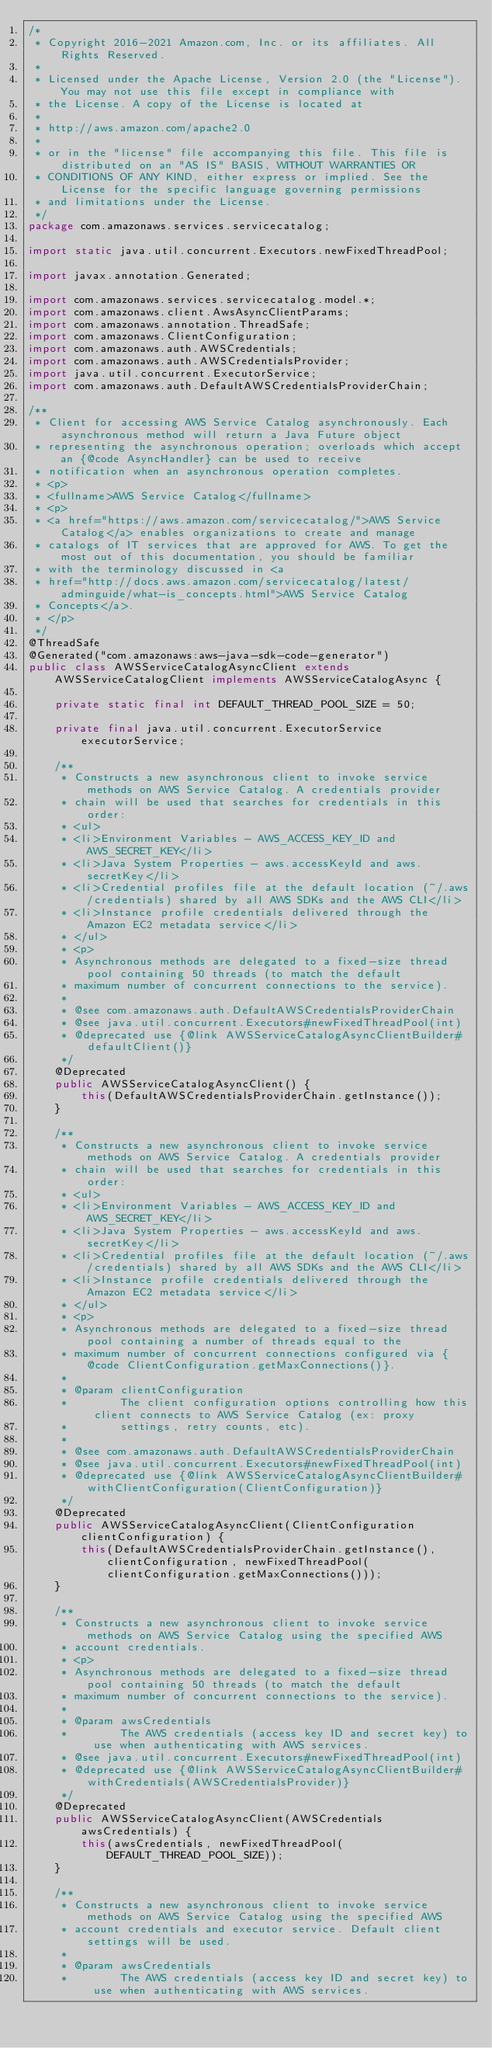<code> <loc_0><loc_0><loc_500><loc_500><_Java_>/*
 * Copyright 2016-2021 Amazon.com, Inc. or its affiliates. All Rights Reserved.
 * 
 * Licensed under the Apache License, Version 2.0 (the "License"). You may not use this file except in compliance with
 * the License. A copy of the License is located at
 * 
 * http://aws.amazon.com/apache2.0
 * 
 * or in the "license" file accompanying this file. This file is distributed on an "AS IS" BASIS, WITHOUT WARRANTIES OR
 * CONDITIONS OF ANY KIND, either express or implied. See the License for the specific language governing permissions
 * and limitations under the License.
 */
package com.amazonaws.services.servicecatalog;

import static java.util.concurrent.Executors.newFixedThreadPool;

import javax.annotation.Generated;

import com.amazonaws.services.servicecatalog.model.*;
import com.amazonaws.client.AwsAsyncClientParams;
import com.amazonaws.annotation.ThreadSafe;
import com.amazonaws.ClientConfiguration;
import com.amazonaws.auth.AWSCredentials;
import com.amazonaws.auth.AWSCredentialsProvider;
import java.util.concurrent.ExecutorService;
import com.amazonaws.auth.DefaultAWSCredentialsProviderChain;

/**
 * Client for accessing AWS Service Catalog asynchronously. Each asynchronous method will return a Java Future object
 * representing the asynchronous operation; overloads which accept an {@code AsyncHandler} can be used to receive
 * notification when an asynchronous operation completes.
 * <p>
 * <fullname>AWS Service Catalog</fullname>
 * <p>
 * <a href="https://aws.amazon.com/servicecatalog/">AWS Service Catalog</a> enables organizations to create and manage
 * catalogs of IT services that are approved for AWS. To get the most out of this documentation, you should be familiar
 * with the terminology discussed in <a
 * href="http://docs.aws.amazon.com/servicecatalog/latest/adminguide/what-is_concepts.html">AWS Service Catalog
 * Concepts</a>.
 * </p>
 */
@ThreadSafe
@Generated("com.amazonaws:aws-java-sdk-code-generator")
public class AWSServiceCatalogAsyncClient extends AWSServiceCatalogClient implements AWSServiceCatalogAsync {

    private static final int DEFAULT_THREAD_POOL_SIZE = 50;

    private final java.util.concurrent.ExecutorService executorService;

    /**
     * Constructs a new asynchronous client to invoke service methods on AWS Service Catalog. A credentials provider
     * chain will be used that searches for credentials in this order:
     * <ul>
     * <li>Environment Variables - AWS_ACCESS_KEY_ID and AWS_SECRET_KEY</li>
     * <li>Java System Properties - aws.accessKeyId and aws.secretKey</li>
     * <li>Credential profiles file at the default location (~/.aws/credentials) shared by all AWS SDKs and the AWS CLI</li>
     * <li>Instance profile credentials delivered through the Amazon EC2 metadata service</li>
     * </ul>
     * <p>
     * Asynchronous methods are delegated to a fixed-size thread pool containing 50 threads (to match the default
     * maximum number of concurrent connections to the service).
     *
     * @see com.amazonaws.auth.DefaultAWSCredentialsProviderChain
     * @see java.util.concurrent.Executors#newFixedThreadPool(int)
     * @deprecated use {@link AWSServiceCatalogAsyncClientBuilder#defaultClient()}
     */
    @Deprecated
    public AWSServiceCatalogAsyncClient() {
        this(DefaultAWSCredentialsProviderChain.getInstance());
    }

    /**
     * Constructs a new asynchronous client to invoke service methods on AWS Service Catalog. A credentials provider
     * chain will be used that searches for credentials in this order:
     * <ul>
     * <li>Environment Variables - AWS_ACCESS_KEY_ID and AWS_SECRET_KEY</li>
     * <li>Java System Properties - aws.accessKeyId and aws.secretKey</li>
     * <li>Credential profiles file at the default location (~/.aws/credentials) shared by all AWS SDKs and the AWS CLI</li>
     * <li>Instance profile credentials delivered through the Amazon EC2 metadata service</li>
     * </ul>
     * <p>
     * Asynchronous methods are delegated to a fixed-size thread pool containing a number of threads equal to the
     * maximum number of concurrent connections configured via {@code ClientConfiguration.getMaxConnections()}.
     *
     * @param clientConfiguration
     *        The client configuration options controlling how this client connects to AWS Service Catalog (ex: proxy
     *        settings, retry counts, etc).
     *
     * @see com.amazonaws.auth.DefaultAWSCredentialsProviderChain
     * @see java.util.concurrent.Executors#newFixedThreadPool(int)
     * @deprecated use {@link AWSServiceCatalogAsyncClientBuilder#withClientConfiguration(ClientConfiguration)}
     */
    @Deprecated
    public AWSServiceCatalogAsyncClient(ClientConfiguration clientConfiguration) {
        this(DefaultAWSCredentialsProviderChain.getInstance(), clientConfiguration, newFixedThreadPool(clientConfiguration.getMaxConnections()));
    }

    /**
     * Constructs a new asynchronous client to invoke service methods on AWS Service Catalog using the specified AWS
     * account credentials.
     * <p>
     * Asynchronous methods are delegated to a fixed-size thread pool containing 50 threads (to match the default
     * maximum number of concurrent connections to the service).
     *
     * @param awsCredentials
     *        The AWS credentials (access key ID and secret key) to use when authenticating with AWS services.
     * @see java.util.concurrent.Executors#newFixedThreadPool(int)
     * @deprecated use {@link AWSServiceCatalogAsyncClientBuilder#withCredentials(AWSCredentialsProvider)}
     */
    @Deprecated
    public AWSServiceCatalogAsyncClient(AWSCredentials awsCredentials) {
        this(awsCredentials, newFixedThreadPool(DEFAULT_THREAD_POOL_SIZE));
    }

    /**
     * Constructs a new asynchronous client to invoke service methods on AWS Service Catalog using the specified AWS
     * account credentials and executor service. Default client settings will be used.
     *
     * @param awsCredentials
     *        The AWS credentials (access key ID and secret key) to use when authenticating with AWS services.</code> 